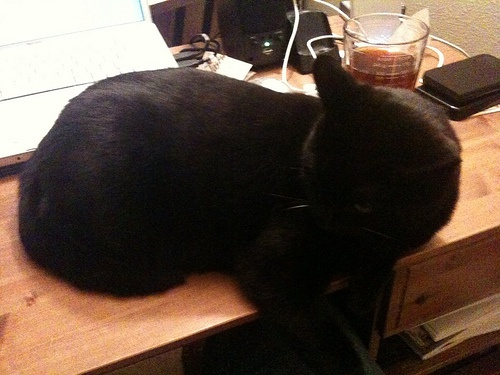Describe the objects in this image and their specific colors. I can see cat in ivory, black, gray, and maroon tones, laptop in ivory, gray, black, and darkgray tones, cup in ivory, tan, maroon, and brown tones, cell phone in ivory, maroon, black, and brown tones, and book in ivory, black, gray, and maroon tones in this image. 